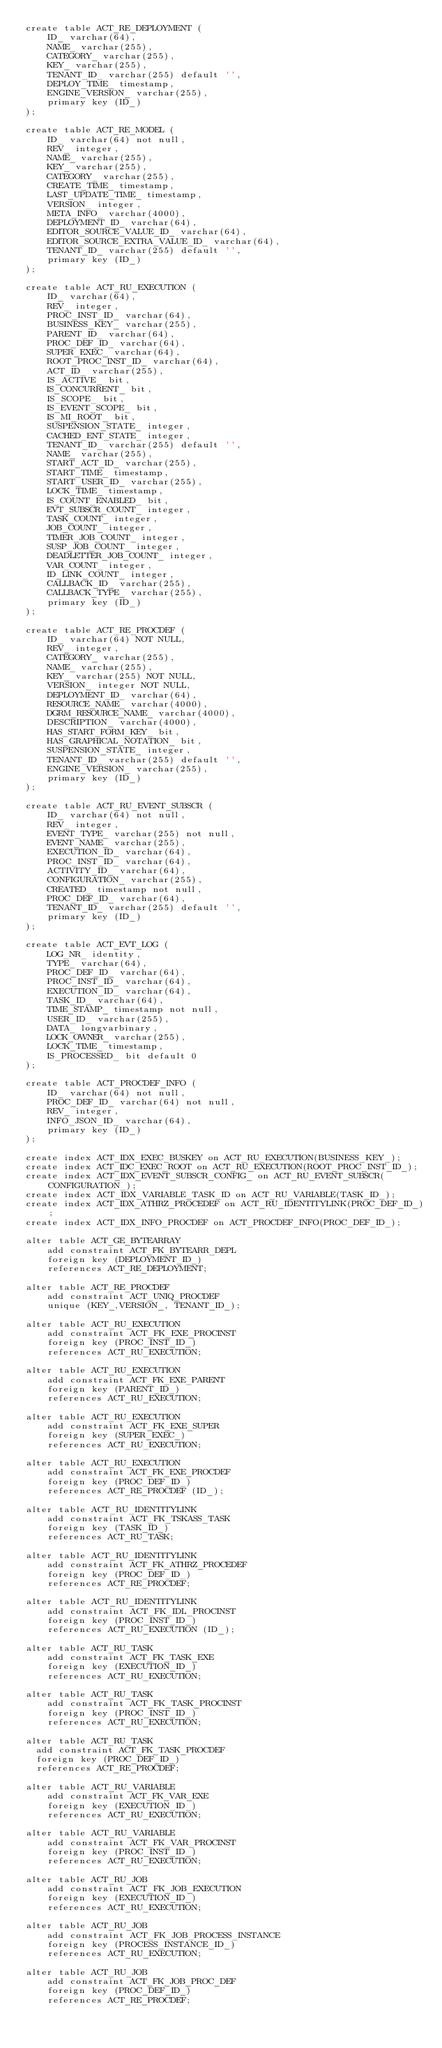Convert code to text. <code><loc_0><loc_0><loc_500><loc_500><_SQL_>create table ACT_RE_DEPLOYMENT (
    ID_ varchar(64),
    NAME_ varchar(255),
    CATEGORY_ varchar(255),
    KEY_ varchar(255),
    TENANT_ID_ varchar(255) default '',
    DEPLOY_TIME_ timestamp,
    ENGINE_VERSION_ varchar(255),
    primary key (ID_)
);

create table ACT_RE_MODEL (
    ID_ varchar(64) not null,
    REV_ integer,
    NAME_ varchar(255),
    KEY_ varchar(255),
    CATEGORY_ varchar(255),
    CREATE_TIME_ timestamp,
    LAST_UPDATE_TIME_ timestamp,
    VERSION_ integer,
    META_INFO_ varchar(4000),
    DEPLOYMENT_ID_ varchar(64),
    EDITOR_SOURCE_VALUE_ID_ varchar(64),
    EDITOR_SOURCE_EXTRA_VALUE_ID_ varchar(64),
    TENANT_ID_ varchar(255) default '',
    primary key (ID_)
);

create table ACT_RU_EXECUTION (
    ID_ varchar(64),
    REV_ integer,
    PROC_INST_ID_ varchar(64),
    BUSINESS_KEY_ varchar(255),
    PARENT_ID_ varchar(64),
    PROC_DEF_ID_ varchar(64),
    SUPER_EXEC_ varchar(64),
    ROOT_PROC_INST_ID_ varchar(64),
    ACT_ID_ varchar(255),
    IS_ACTIVE_ bit,
    IS_CONCURRENT_ bit,
    IS_SCOPE_ bit,
    IS_EVENT_SCOPE_ bit,
    IS_MI_ROOT_ bit,
    SUSPENSION_STATE_ integer,
    CACHED_ENT_STATE_ integer,
    TENANT_ID_ varchar(255) default '',
    NAME_ varchar(255),
    START_ACT_ID_ varchar(255),
    START_TIME_ timestamp,
    START_USER_ID_ varchar(255),
    LOCK_TIME_ timestamp,
    IS_COUNT_ENABLED_ bit,
    EVT_SUBSCR_COUNT_ integer, 
    TASK_COUNT_ integer, 
    JOB_COUNT_ integer, 
    TIMER_JOB_COUNT_ integer,
    SUSP_JOB_COUNT_ integer,
    DEADLETTER_JOB_COUNT_ integer,
    VAR_COUNT_ integer, 
    ID_LINK_COUNT_ integer,
    CALLBACK_ID_ varchar(255),
    CALLBACK_TYPE_ varchar(255),
    primary key (ID_)
);

create table ACT_RE_PROCDEF (
    ID_ varchar(64) NOT NULL,
    REV_ integer,
    CATEGORY_ varchar(255),
    NAME_ varchar(255),
    KEY_ varchar(255) NOT NULL,
    VERSION_ integer NOT NULL,
    DEPLOYMENT_ID_ varchar(64),
    RESOURCE_NAME_ varchar(4000),
    DGRM_RESOURCE_NAME_ varchar(4000),
    DESCRIPTION_ varchar(4000),
    HAS_START_FORM_KEY_ bit,
    HAS_GRAPHICAL_NOTATION_ bit,
    SUSPENSION_STATE_ integer,
    TENANT_ID_ varchar(255) default '',
    ENGINE_VERSION_ varchar(255),
    primary key (ID_)
);

create table ACT_RU_EVENT_SUBSCR (
    ID_ varchar(64) not null,
    REV_ integer,
    EVENT_TYPE_ varchar(255) not null,
    EVENT_NAME_ varchar(255),
    EXECUTION_ID_ varchar(64),
    PROC_INST_ID_ varchar(64),
    ACTIVITY_ID_ varchar(64),
    CONFIGURATION_ varchar(255),
    CREATED_ timestamp not null,
    PROC_DEF_ID_ varchar(64),
    TENANT_ID_ varchar(255) default '',
    primary key (ID_)
);

create table ACT_EVT_LOG (
    LOG_NR_ identity,
    TYPE_ varchar(64),
    PROC_DEF_ID_ varchar(64),
    PROC_INST_ID_ varchar(64),
    EXECUTION_ID_ varchar(64),
    TASK_ID_ varchar(64),
    TIME_STAMP_ timestamp not null,
    USER_ID_ varchar(255),
    DATA_ longvarbinary,
    LOCK_OWNER_ varchar(255),
    LOCK_TIME_ timestamp,
    IS_PROCESSED_ bit default 0
);

create table ACT_PROCDEF_INFO (
	ID_ varchar(64) not null,
    PROC_DEF_ID_ varchar(64) not null,
    REV_ integer,
    INFO_JSON_ID_ varchar(64),
    primary key (ID_)
);

create index ACT_IDX_EXEC_BUSKEY on ACT_RU_EXECUTION(BUSINESS_KEY_);
create index ACT_IDC_EXEC_ROOT on ACT_RU_EXECUTION(ROOT_PROC_INST_ID_);
create index ACT_IDX_EVENT_SUBSCR_CONFIG_ on ACT_RU_EVENT_SUBSCR(CONFIGURATION_);
create index ACT_IDX_VARIABLE_TASK_ID on ACT_RU_VARIABLE(TASK_ID_);
create index ACT_IDX_ATHRZ_PROCEDEF on ACT_RU_IDENTITYLINK(PROC_DEF_ID_);
create index ACT_IDX_INFO_PROCDEF on ACT_PROCDEF_INFO(PROC_DEF_ID_);

alter table ACT_GE_BYTEARRAY
    add constraint ACT_FK_BYTEARR_DEPL
    foreign key (DEPLOYMENT_ID_)
    references ACT_RE_DEPLOYMENT;

alter table ACT_RE_PROCDEF
    add constraint ACT_UNIQ_PROCDEF
    unique (KEY_,VERSION_, TENANT_ID_);
    
alter table ACT_RU_EXECUTION
    add constraint ACT_FK_EXE_PROCINST
    foreign key (PROC_INST_ID_)
    references ACT_RU_EXECUTION;

alter table ACT_RU_EXECUTION
    add constraint ACT_FK_EXE_PARENT
    foreign key (PARENT_ID_)
    references ACT_RU_EXECUTION;
    
alter table ACT_RU_EXECUTION
    add constraint ACT_FK_EXE_SUPER 
    foreign key (SUPER_EXEC_) 
    references ACT_RU_EXECUTION;
    
alter table ACT_RU_EXECUTION
    add constraint ACT_FK_EXE_PROCDEF 
    foreign key (PROC_DEF_ID_) 
    references ACT_RE_PROCDEF (ID_);    
    
alter table ACT_RU_IDENTITYLINK
    add constraint ACT_FK_TSKASS_TASK
    foreign key (TASK_ID_)
    references ACT_RU_TASK;

alter table ACT_RU_IDENTITYLINK
    add constraint ACT_FK_ATHRZ_PROCEDEF
    foreign key (PROC_DEF_ID_)
    references ACT_RE_PROCDEF;
    
alter table ACT_RU_IDENTITYLINK
    add constraint ACT_FK_IDL_PROCINST
    foreign key (PROC_INST_ID_) 
    references ACT_RU_EXECUTION (ID_);       

alter table ACT_RU_TASK
    add constraint ACT_FK_TASK_EXE
    foreign key (EXECUTION_ID_)
    references ACT_RU_EXECUTION;

alter table ACT_RU_TASK
    add constraint ACT_FK_TASK_PROCINST
    foreign key (PROC_INST_ID_)
    references ACT_RU_EXECUTION;

alter table ACT_RU_TASK
  add constraint ACT_FK_TASK_PROCDEF
  foreign key (PROC_DEF_ID_)
  references ACT_RE_PROCDEF;

alter table ACT_RU_VARIABLE
    add constraint ACT_FK_VAR_EXE
    foreign key (EXECUTION_ID_)
    references ACT_RU_EXECUTION;

alter table ACT_RU_VARIABLE
    add constraint ACT_FK_VAR_PROCINST
    foreign key (PROC_INST_ID_)
    references ACT_RU_EXECUTION;

alter table ACT_RU_JOB
    add constraint ACT_FK_JOB_EXECUTION
    foreign key (EXECUTION_ID_)
    references ACT_RU_EXECUTION;
    
alter table ACT_RU_JOB
    add constraint ACT_FK_JOB_PROCESS_INSTANCE
    foreign key (PROCESS_INSTANCE_ID_)
    references ACT_RU_EXECUTION;
    
alter table ACT_RU_JOB
    add constraint ACT_FK_JOB_PROC_DEF
    foreign key (PROC_DEF_ID_)
    references ACT_RE_PROCDEF;
    </code> 